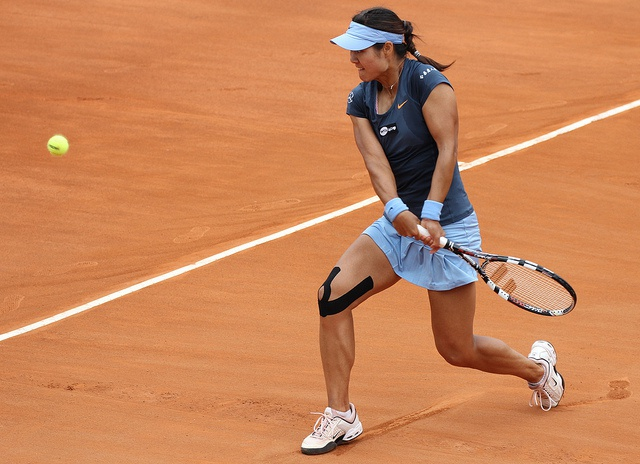Describe the objects in this image and their specific colors. I can see people in salmon, black, brown, and tan tones, tennis racket in salmon, tan, lightgray, and black tones, and sports ball in salmon, khaki, olive, and tan tones in this image. 